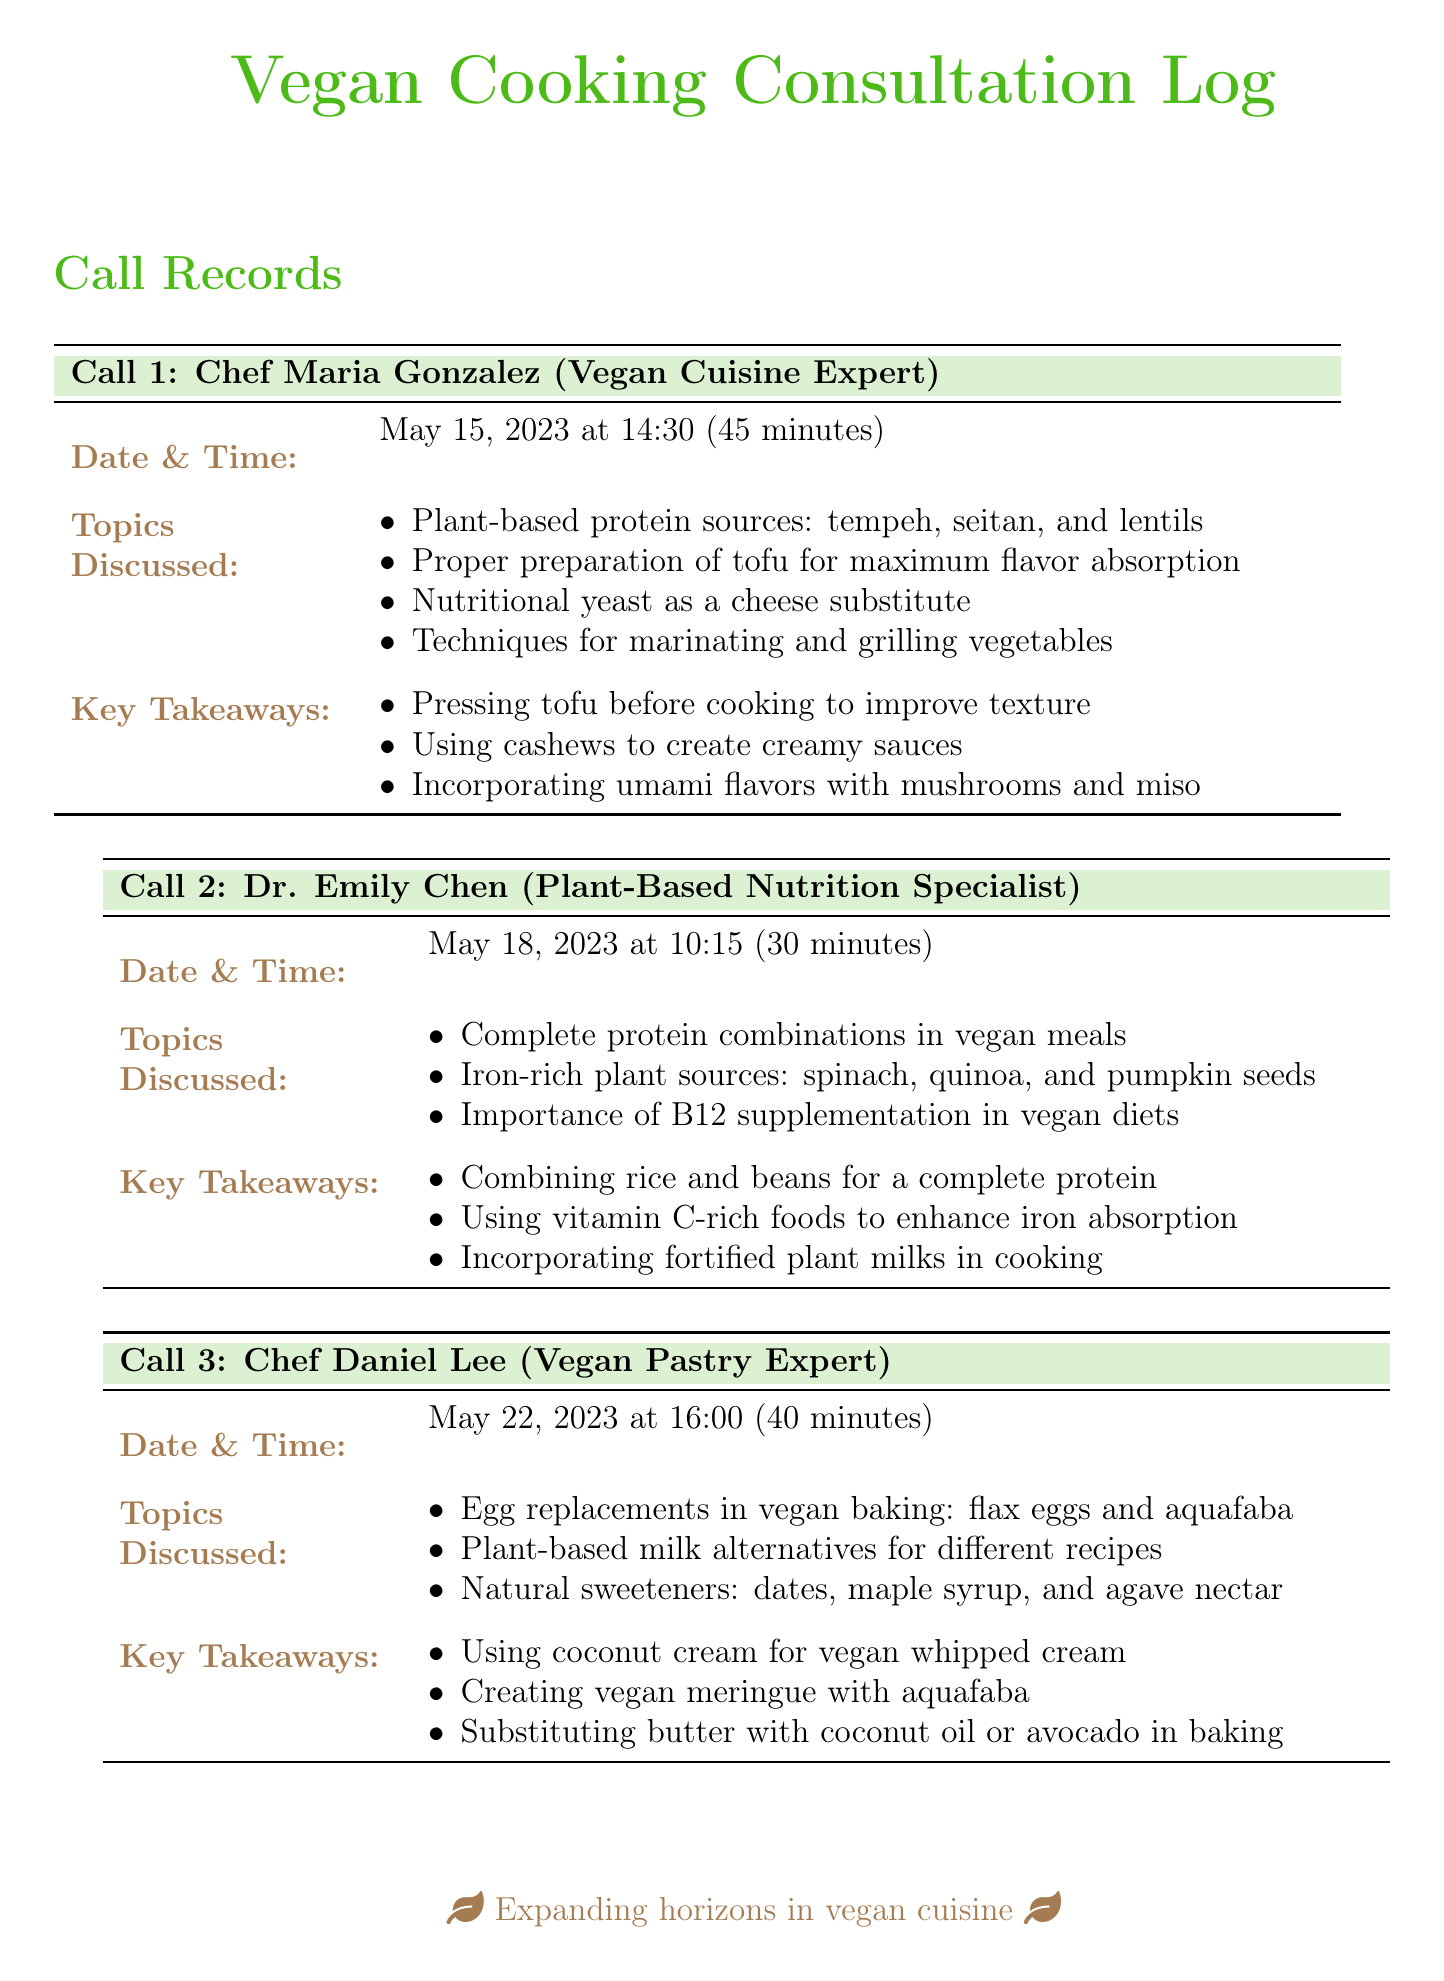what is the name of the first expert? The first expert mentioned is Chef Maria Gonzalez.
Answer: Chef Maria Gonzalez when did the call with Dr. Emily Chen take place? The call with Dr. Emily Chen occurred on May 18, 2023 at 10:15.
Answer: May 18, 2023 at 10:15 how long was the call with Chef Daniel Lee? The call with Chef Daniel Lee lasted 40 minutes.
Answer: 40 minutes what plant-based sources were discussed for protein in Call 1? In Call 1, the discussed plant-based protein sources were tempeh, seitan, and lentils.
Answer: tempeh, seitan, and lentils what combination is suggested for complete protein in vegan meals? The combination suggested for complete protein is rice and beans.
Answer: rice and beans which alternative is mentioned for egg replacements in baking? The alternatives for egg replacements mentioned are flax eggs and aquafaba.
Answer: flax eggs and aquafaba what is a key takeaway about tofu preparation? A key takeaway is to press tofu before cooking to improve texture.
Answer: press tofu before cooking what sweeteners are recommended for vegan baking? The recommended natural sweeteners are dates, maple syrup, and agave nectar.
Answer: dates, maple syrup, and agave nectar who is the last expert consulted in the document? The last expert consulted is Chef Daniel Lee.
Answer: Chef Daniel Lee 